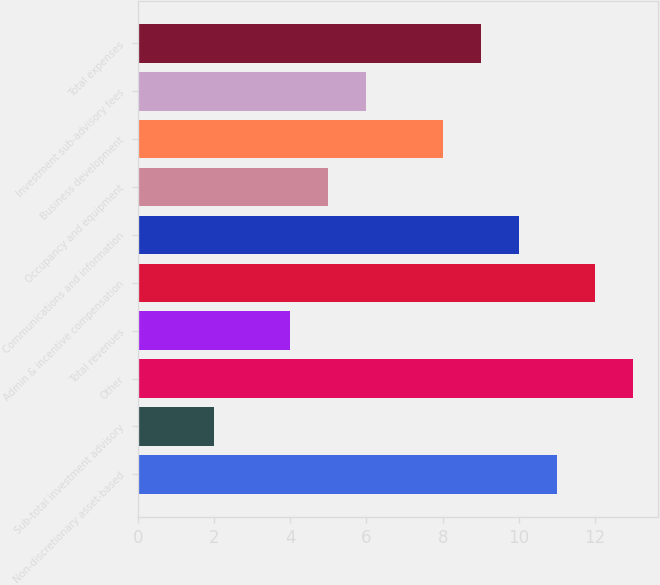<chart> <loc_0><loc_0><loc_500><loc_500><bar_chart><fcel>Non-discretionary asset-based<fcel>Sub-total investment advisory<fcel>Other<fcel>Total revenues<fcel>Admin & incentive compensation<fcel>Communications and information<fcel>Occupancy and equipment<fcel>Business development<fcel>Investment sub-advisory fees<fcel>Total expenses<nl><fcel>11<fcel>2<fcel>13<fcel>4<fcel>12<fcel>10<fcel>5<fcel>8<fcel>6<fcel>9<nl></chart> 